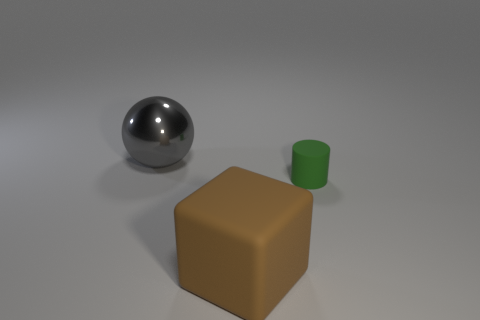What size is the green object that is made of the same material as the big brown block? The green object appears to be relatively small, especially when compared to the big brown block. Despite the difference in size, it shares a similar smooth and matte texture with the block, suggesting they are made of the same material. 